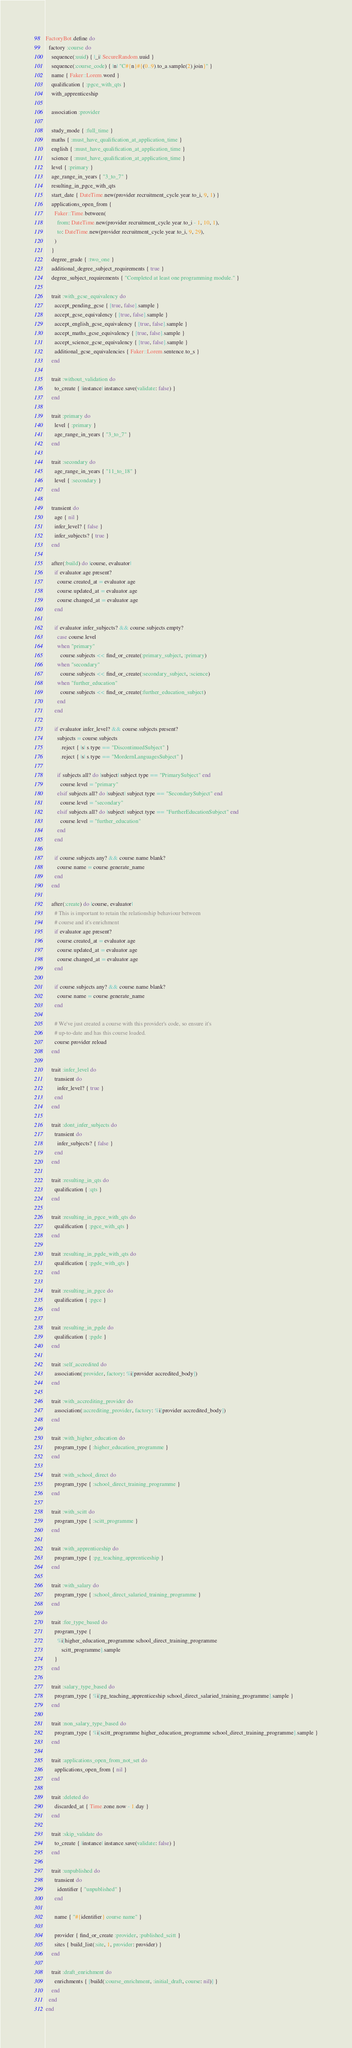Convert code to text. <code><loc_0><loc_0><loc_500><loc_500><_Ruby_>FactoryBot.define do
  factory :course do
    sequence(:uuid) { |_i| SecureRandom.uuid }
    sequence(:course_code) { |n| "C#{n}#{(0..9).to_a.sample(2).join}" }
    name { Faker::Lorem.word }
    qualification { :pgce_with_qts }
    with_apprenticeship

    association :provider

    study_mode { :full_time }
    maths { :must_have_qualification_at_application_time }
    english { :must_have_qualification_at_application_time }
    science { :must_have_qualification_at_application_time }
    level { :primary }
    age_range_in_years { "3_to_7" }
    resulting_in_pgce_with_qts
    start_date { DateTime.new(provider.recruitment_cycle.year.to_i, 9, 1) }
    applications_open_from {
      Faker::Time.between(
        from: DateTime.new(provider.recruitment_cycle.year.to_i - 1, 10, 1),
        to: DateTime.new(provider.recruitment_cycle.year.to_i, 9, 29),
      )
    }
    degree_grade { :two_one }
    additional_degree_subject_requirements { true }
    degree_subject_requirements { "Completed at least one programming module." }

    trait :with_gcse_equivalency do
      accept_pending_gcse { [true, false].sample }
      accept_gcse_equivalency { [true, false].sample }
      accept_english_gcse_equivalency { [true, false].sample }
      accept_maths_gcse_equivalency { [true, false].sample }
      accept_science_gcse_equivalency { [true, false].sample }
      additional_gcse_equivalencies { Faker::Lorem.sentence.to_s }
    end

    trait :without_validation do
      to_create { |instance| instance.save(validate: false) }
    end

    trait :primary do
      level { :primary }
      age_range_in_years { "3_to_7" }
    end

    trait :secondary do
      age_range_in_years { "11_to_18" }
      level { :secondary }
    end

    transient do
      age { nil }
      infer_level? { false }
      infer_subjects? { true }
    end

    after(:build) do |course, evaluator|
      if evaluator.age.present?
        course.created_at = evaluator.age
        course.updated_at = evaluator.age
        course.changed_at = evaluator.age
      end

      if evaluator.infer_subjects? && course.subjects.empty?
        case course.level
        when "primary"
          course.subjects << find_or_create(:primary_subject, :primary)
        when "secondary"
          course.subjects << find_or_create(:secondary_subject, :science)
        when "further_education"
          course.subjects << find_or_create(:further_education_subject)
        end
      end

      if evaluator.infer_level? && course.subjects.present?
        subjects = course.subjects
          .reject { |s| s.type == "DiscontinuedSubject" }
          .reject { |s| s.type == "MordernLanguagesSubject" }

        if subjects.all? do |subject| subject.type == "PrimarySubject" end
          course.level = "primary"
        elsif subjects.all? do |subject| subject.type == "SecondarySubject" end
          course.level = "secondary"
        elsif subjects.all? do |subject| subject.type == "FurtherEducationSubject" end
          course.level = "further_education"
        end
      end

      if course.subjects.any? && course.name.blank?
        course.name = course.generate_name
      end
    end

    after(:create) do |course, evaluator|
      # This is important to retain the relationship behaviour between
      # course and it's enrichment
      if evaluator.age.present?
        course.created_at = evaluator.age
        course.updated_at = evaluator.age
        course.changed_at = evaluator.age
      end

      if course.subjects.any? && course.name.blank?
        course.name = course.generate_name
      end

      # We've just created a course with this provider's code, so ensure it's
      # up-to-date and has this course loaded.
      course.provider.reload
    end

    trait :infer_level do
      transient do
        infer_level? { true }
      end
    end

    trait :dont_infer_subjects do
      transient do
        infer_subjects? { false }
      end
    end

    trait :resulting_in_qts do
      qualification { :qts }
    end

    trait :resulting_in_pgce_with_qts do
      qualification { :pgce_with_qts }
    end

    trait :resulting_in_pgde_with_qts do
      qualification { :pgde_with_qts }
    end

    trait :resulting_in_pgce do
      qualification { :pgce }
    end

    trait :resulting_in_pgde do
      qualification { :pgde }
    end

    trait :self_accredited do
      association(:provider, factory: %i[provider accredited_body])
    end

    trait :with_accrediting_provider do
      association(:accrediting_provider, factory: %i[provider accredited_body])
    end

    trait :with_higher_education do
      program_type { :higher_education_programme }
    end

    trait :with_school_direct do
      program_type { :school_direct_training_programme }
    end

    trait :with_scitt do
      program_type { :scitt_programme }
    end

    trait :with_apprenticeship do
      program_type { :pg_teaching_apprenticeship }
    end

    trait :with_salary do
      program_type { :school_direct_salaried_training_programme }
    end

    trait :fee_type_based do
      program_type {
        %i[higher_education_programme school_direct_training_programme
           scitt_programme].sample
      }
    end

    trait :salary_type_based do
      program_type { %i[pg_teaching_apprenticeship school_direct_salaried_training_programme].sample }
    end

    trait :non_salary_type_based do
      program_type { %i[scitt_programme higher_education_programme school_direct_training_programme].sample }
    end

    trait :applications_open_from_not_set do
      applications_open_from { nil }
    end

    trait :deleted do
      discarded_at { Time.zone.now - 1.day }
    end

    trait :skip_validate do
      to_create { |instance| instance.save(validate: false) }
    end

    trait :unpublished do
      transient do
        identifier { "unpublished" }
      end

      name { "#{identifier} course name" }

      provider { find_or_create :provider, :published_scitt }
      sites { build_list(:site, 1, provider: provider) }
    end

    trait :draft_enrichment do
      enrichments { [build(:course_enrichment, :initial_draft, course: nil)] }
    end
  end
end
</code> 